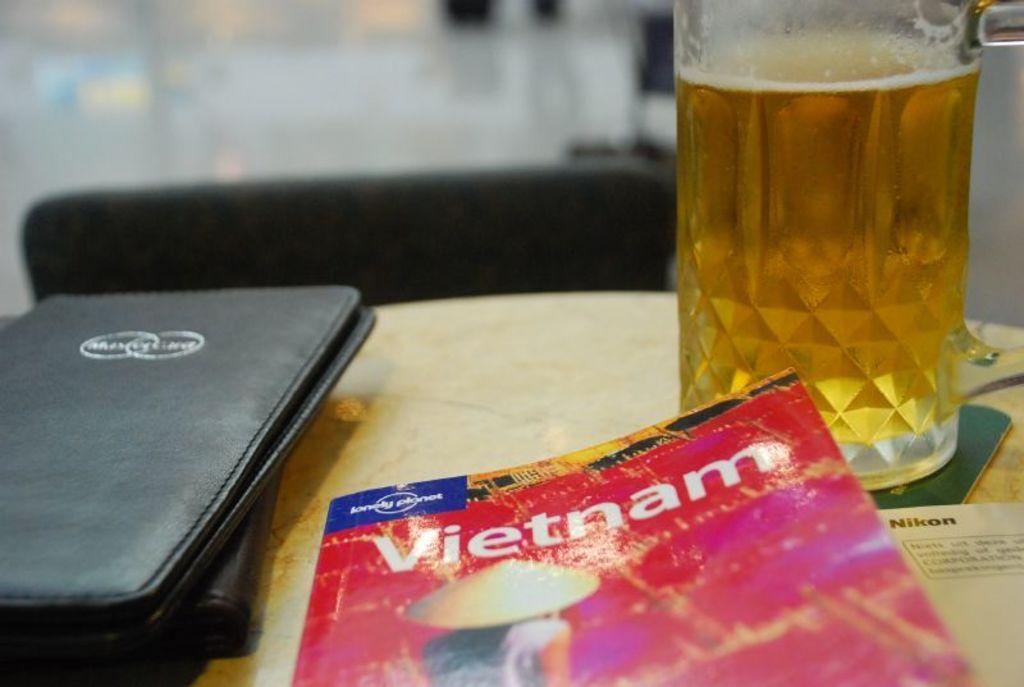Where is this travel book for?
Give a very brief answer. Vietnam. What is the title of this book?
Your answer should be very brief. Vietnam. 